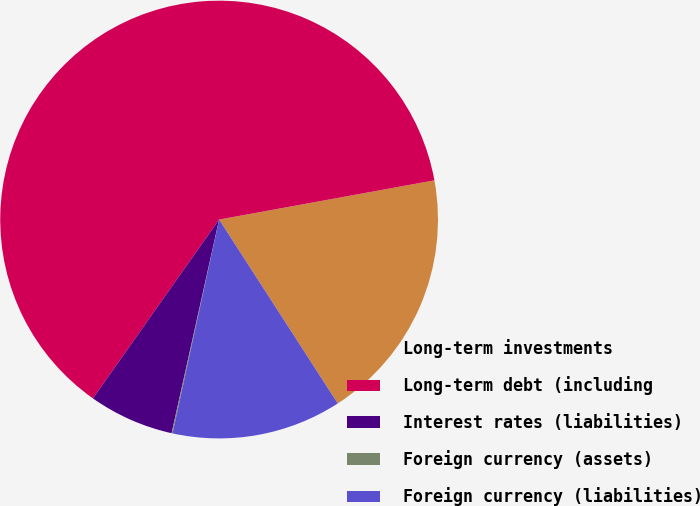<chart> <loc_0><loc_0><loc_500><loc_500><pie_chart><fcel>Long-term investments<fcel>Long-term debt (including<fcel>Interest rates (liabilities)<fcel>Foreign currency (assets)<fcel>Foreign currency (liabilities)<nl><fcel>18.75%<fcel>62.36%<fcel>6.3%<fcel>0.07%<fcel>12.53%<nl></chart> 